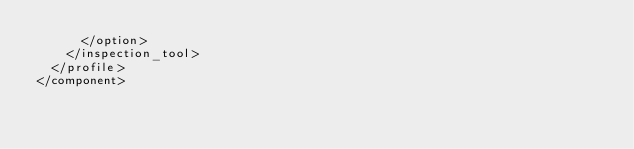Convert code to text. <code><loc_0><loc_0><loc_500><loc_500><_XML_>      </option>
    </inspection_tool>
  </profile>
</component></code> 